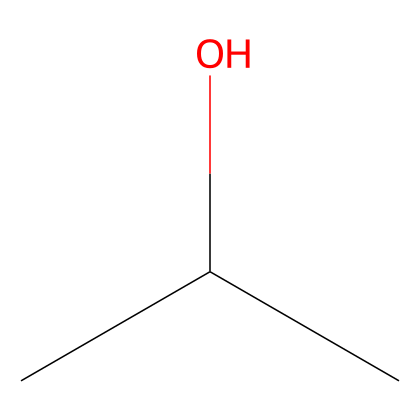What is the IUPAC name of this chemical? The SMILES representation "CC(C)O" indicates the structure of isopropyl alcohol, which consists of three carbon atoms, eight hydrogen atoms, and one hydroxyl (OH) group. The IUPAC name is derived from the longest carbon chain and the functional group present.
Answer: isopropyl alcohol How many carbon atoms are present in this molecule? Analyzing the SMILES notation "CC(C)O," we can identify that there are three carbon atoms represented by the three 'C's.
Answer: three What type of functional group is present in isopropyl alcohol? Looking at the structure, the -OH group is known as a hydroxyl group, which classifies this compound as an alcohol.
Answer: hydroxyl What is the molecular formula of isopropyl alcohol? From the SMILES "CC(C)O," we can deduce the molecular formula by counting the atoms: 3 carbon, 8 hydrogen, and 1 oxygen give C3H8O.
Answer: C3H8O Why is isopropyl alcohol considered flammable? The presence of carbon and hydrogen atoms indicates that isopropyl alcohol can easily combust. The flammable nature is due to its ability to form combustible vapors when exposed to heat or flame, which is typical for alcohols.
Answer: flammable What is the boiling point of isopropyl alcohol? Isopropyl alcohol has a boiling point of approximately 82.6 °C, which can be confirmed by referencing chemical databases and literature.
Answer: 82.6 °C 